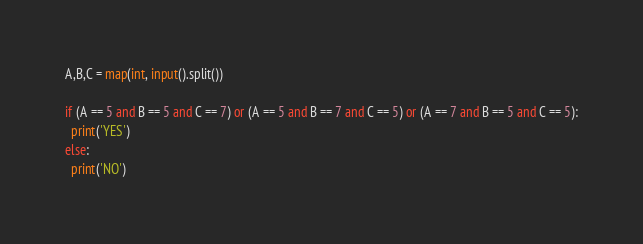Convert code to text. <code><loc_0><loc_0><loc_500><loc_500><_Python_>A,B,C = map(int, input().split())

if (A == 5 and B == 5 and C == 7) or (A == 5 and B == 7 and C == 5) or (A == 7 and B == 5 and C == 5):
  print('YES')
else:
  print('NO')
</code> 